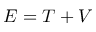Convert formula to latex. <formula><loc_0><loc_0><loc_500><loc_500>E = T + V</formula> 